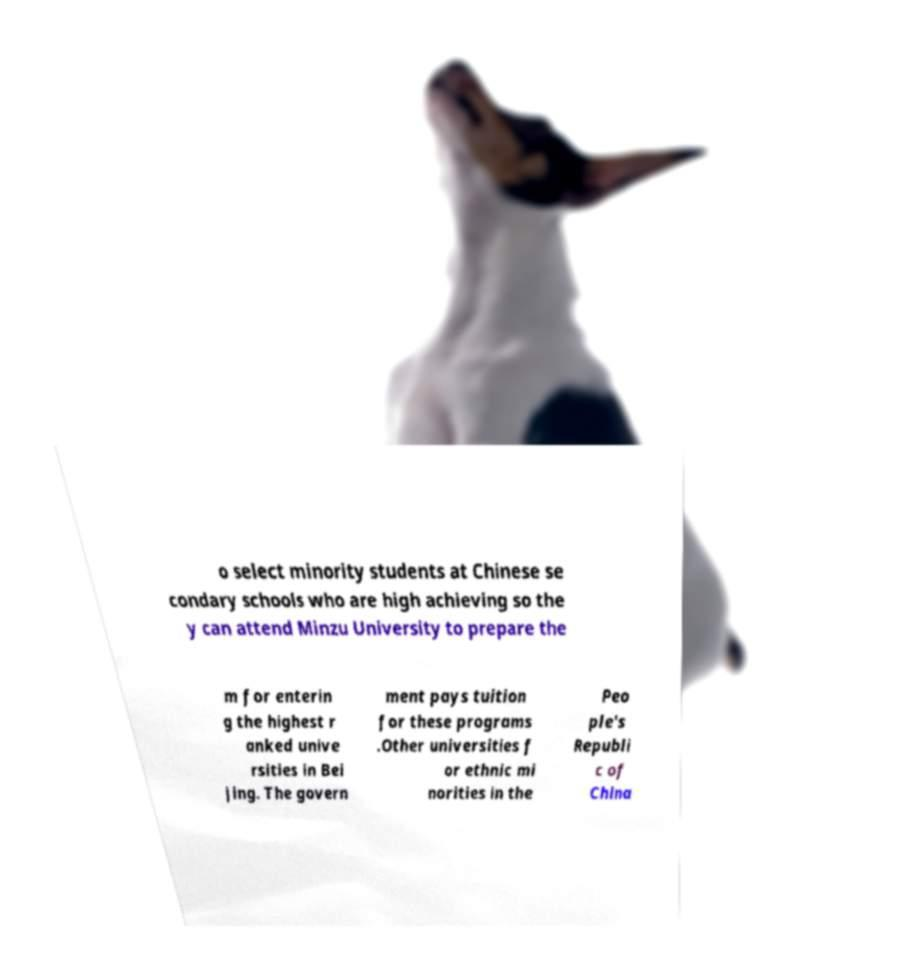Can you accurately transcribe the text from the provided image for me? o select minority students at Chinese se condary schools who are high achieving so the y can attend Minzu University to prepare the m for enterin g the highest r anked unive rsities in Bei jing. The govern ment pays tuition for these programs .Other universities f or ethnic mi norities in the Peo ple's Republi c of China 